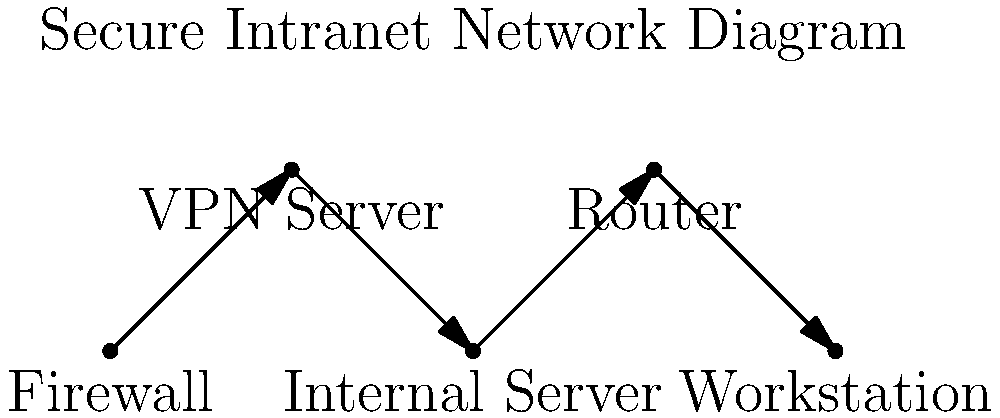In the network diagram shown, which component should be placed immediately after the firewall to ensure secure, encrypted access for remote employees? To set up a secure, private intranet for internal communications, we need to consider the following steps:

1. The firewall is the first line of defense, protecting the internal network from external threats.

2. A VPN (Virtual Private Network) server should be placed immediately after the firewall. This allows remote employees to securely connect to the internal network through an encrypted tunnel, ensuring privacy and security for communications over the internet.

3. The internal server hosts the company's intranet resources and applications. It's placed behind the VPN server to ensure that only authenticated users can access it.

4. The router manages internal network traffic and connects different segments of the intranet.

5. Workstations represent the end-users' computers, which connect to the intranet through the router.

In this setup, the VPN server is crucial for maintaining privacy and security for remote access. It encrypts all traffic between remote employees and the internal network, preventing eavesdropping and unauthorized access. This is especially important for a business owner in South Africa who values privacy, as it protects sensitive business communications from potential threats.
Answer: VPN Server 